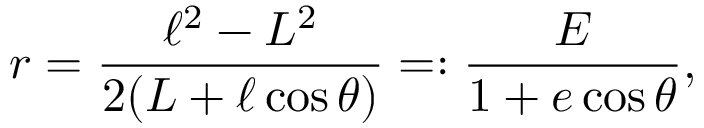<formula> <loc_0><loc_0><loc_500><loc_500>r = \frac { \ell ^ { 2 } - L ^ { 2 } } { 2 ( L + \ell \cos \theta ) } = \colon \frac { E } { 1 + e \cos \theta } ,</formula> 